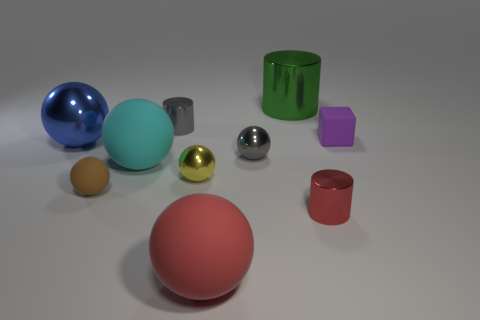Subtract all gray spheres. How many spheres are left? 5 Subtract all large cyan matte spheres. How many spheres are left? 5 Subtract all brown spheres. Subtract all yellow cubes. How many spheres are left? 5 Subtract all cylinders. How many objects are left? 7 Subtract all purple blocks. Subtract all metallic things. How many objects are left? 3 Add 4 yellow objects. How many yellow objects are left? 5 Add 5 small gray metallic objects. How many small gray metallic objects exist? 7 Subtract 1 yellow spheres. How many objects are left? 9 